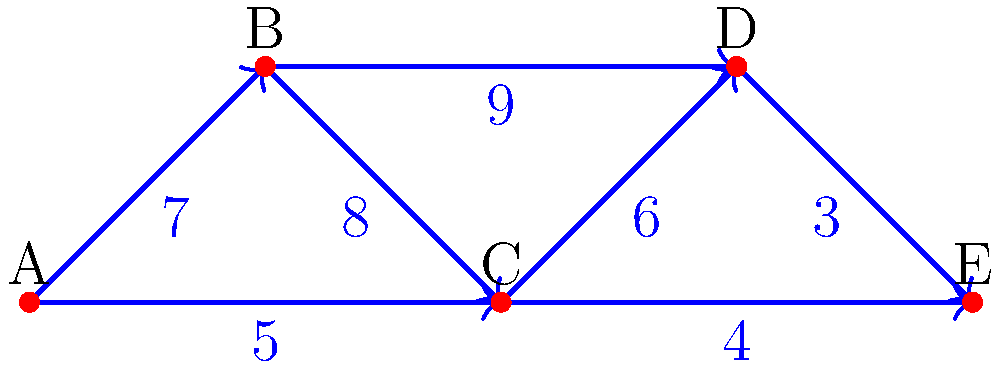As a project manager, you're tasked with connecting five project phases (A, B, C, D, and E) in the most cost-effective manner. The diagram shows the possible connections between phases and their associated costs. What is the minimum total cost to connect all phases, and which connections should be made to achieve this minimum cost? To solve this problem, we need to find the Minimum Spanning Tree (MST) of the given graph. We can use Kruskal's algorithm to find the MST:

1. Sort all edges by weight in ascending order:
   (D, E): 3
   (C, E): 4
   (A, C): 5
   (C, D): 6
   (A, B): 7
   (B, C): 8
   (B, D): 9

2. Start with an empty set of edges and add edges one by one, ensuring no cycles are formed:
   - Add (D, E): 3
   - Add (C, E): 4
   - Add (A, C): 5
   - Add (C, D): 6

3. We now have 4 edges connecting all 5 vertices, so we stop.

The minimum spanning tree consists of the edges:
- (D, E) with cost 3
- (C, E) with cost 4
- (A, C) with cost 5
- (C, D) with cost 6

The total minimum cost is: $3 + 4 + 5 + 6 = 18$

Therefore, to minimize project costs, we should make the following connections:
- Connect phase D to E
- Connect phase C to E
- Connect phase A to C
- Connect phase C to D
Answer: Minimum cost: $18$. Connections: D-E, C-E, A-C, C-D. 